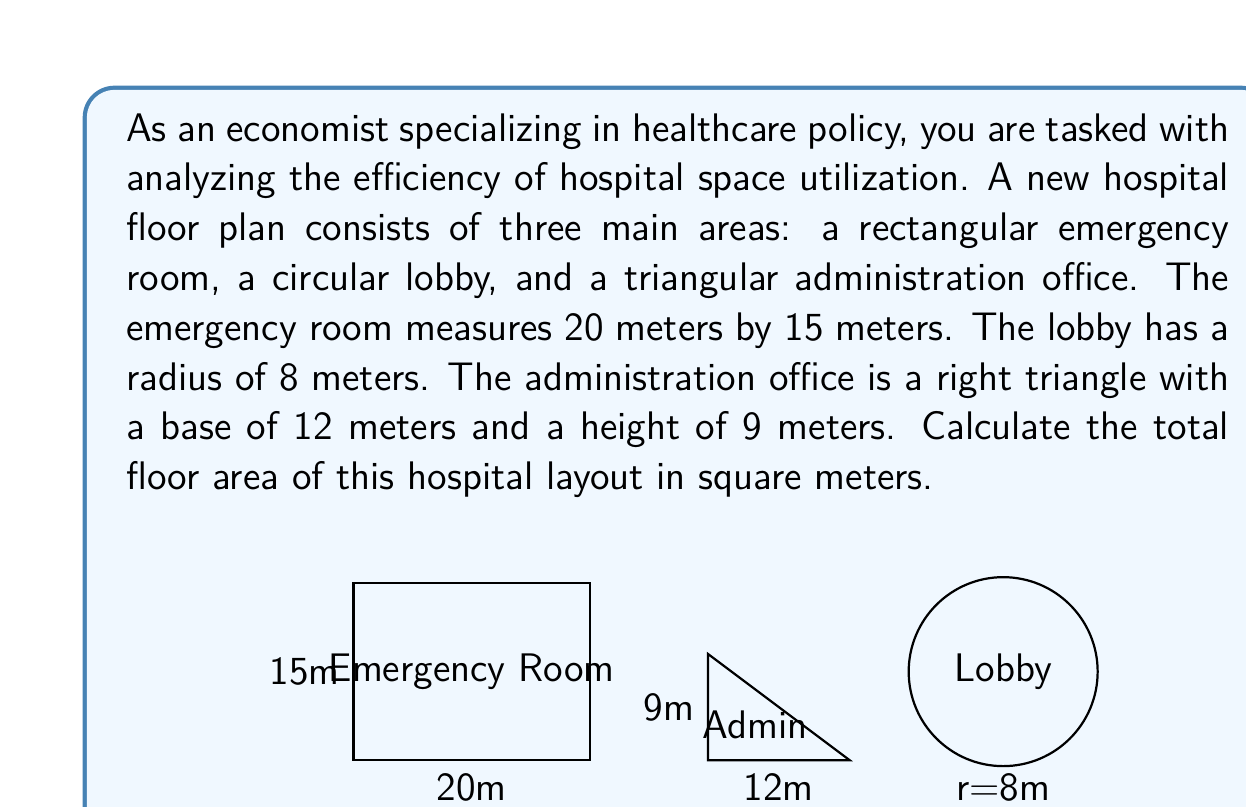Teach me how to tackle this problem. To solve this problem, we need to calculate the area of each geometric shape and then sum them up. Let's break it down step by step:

1. Emergency Room (Rectangle):
   Area of a rectangle = length × width
   $A_{ER} = 20 \text{ m} \times 15 \text{ m} = 300 \text{ m}^2$

2. Lobby (Circle):
   Area of a circle = $\pi r^2$, where $r$ is the radius
   $A_{Lobby} = \pi \times (8 \text{ m})^2 = 64\pi \text{ m}^2$

3. Administration Office (Right Triangle):
   Area of a triangle = $\frac{1}{2} \times \text{base} \times \text{height}$
   $A_{Admin} = \frac{1}{2} \times 12 \text{ m} \times 9 \text{ m} = 54 \text{ m}^2$

4. Total Area:
   $A_{Total} = A_{ER} + A_{Lobby} + A_{Admin}$
   $A_{Total} = 300 \text{ m}^2 + 64\pi \text{ m}^2 + 54 \text{ m}^2$
   $A_{Total} = 354 + 64\pi \text{ m}^2$

To get the final numerical answer, we need to calculate the value of $64\pi$:
$64\pi \approx 201.06 \text{ m}^2$

Therefore, the total area is approximately:
$A_{Total} \approx 354 + 201.06 = 555.06 \text{ m}^2$
Answer: The total floor area of the hospital layout is $354 + 64\pi \text{ m}^2$ or approximately $555.06 \text{ m}^2$. 